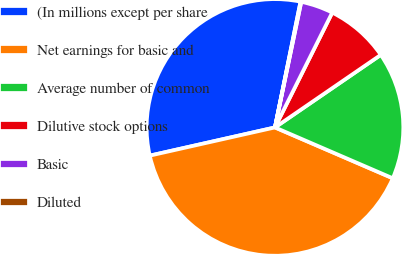Convert chart to OTSL. <chart><loc_0><loc_0><loc_500><loc_500><pie_chart><fcel>(In millions except per share<fcel>Net earnings for basic and<fcel>Average number of common<fcel>Dilutive stock options<fcel>Basic<fcel>Diluted<nl><fcel>31.72%<fcel>39.99%<fcel>16.05%<fcel>8.07%<fcel>4.08%<fcel>0.09%<nl></chart> 